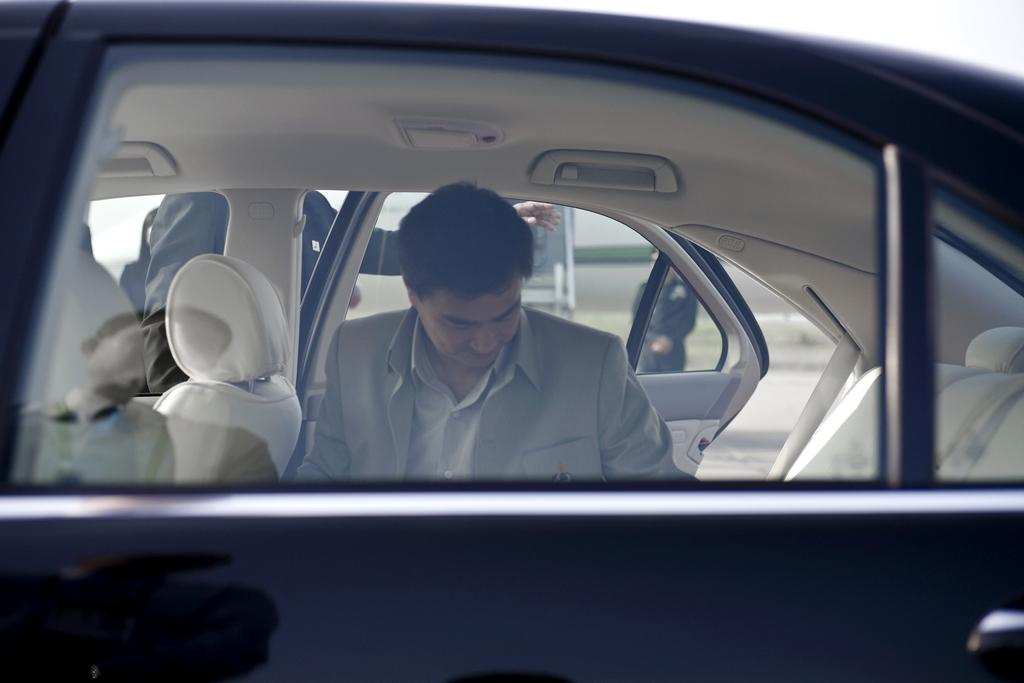What is the position of the person in the car? There is a person sitting inside the car. What is the position of the other person in the image? There is another person standing next to the car. What is the standing person doing? The standing person is holding the car door. How many dimes can be seen on the car's fender in the image? There are no dimes visible on the car's fender in the image. 